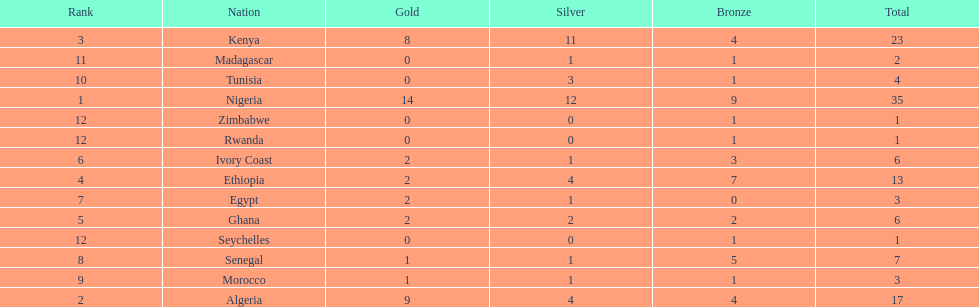Which country had the least bronze medals? Egypt. 